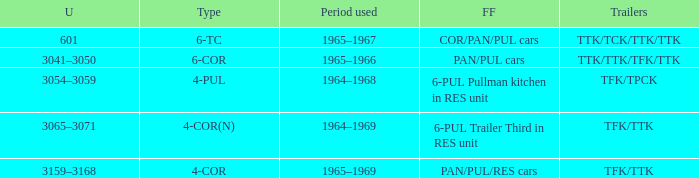Name the trailers for formed from pan/pul/res cars TFK/TTK. 